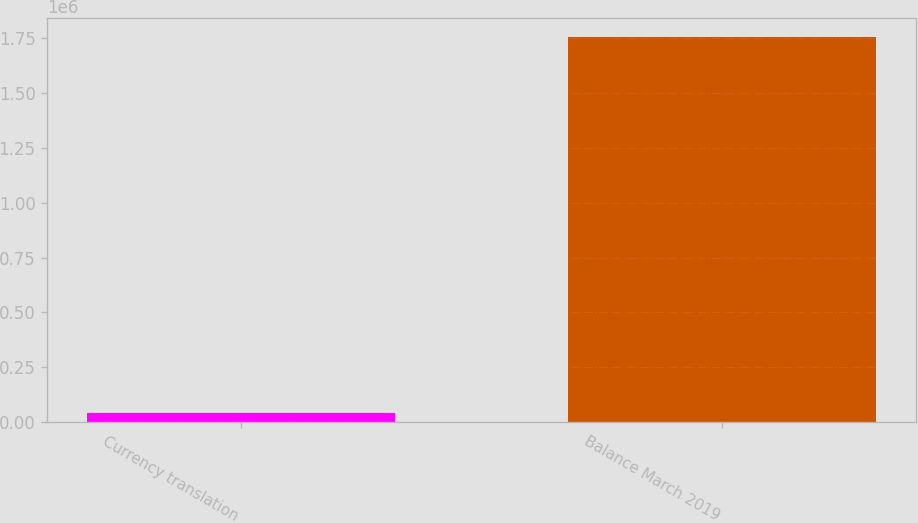<chart> <loc_0><loc_0><loc_500><loc_500><bar_chart><fcel>Currency translation<fcel>Balance March 2019<nl><fcel>41616<fcel>1.75488e+06<nl></chart> 